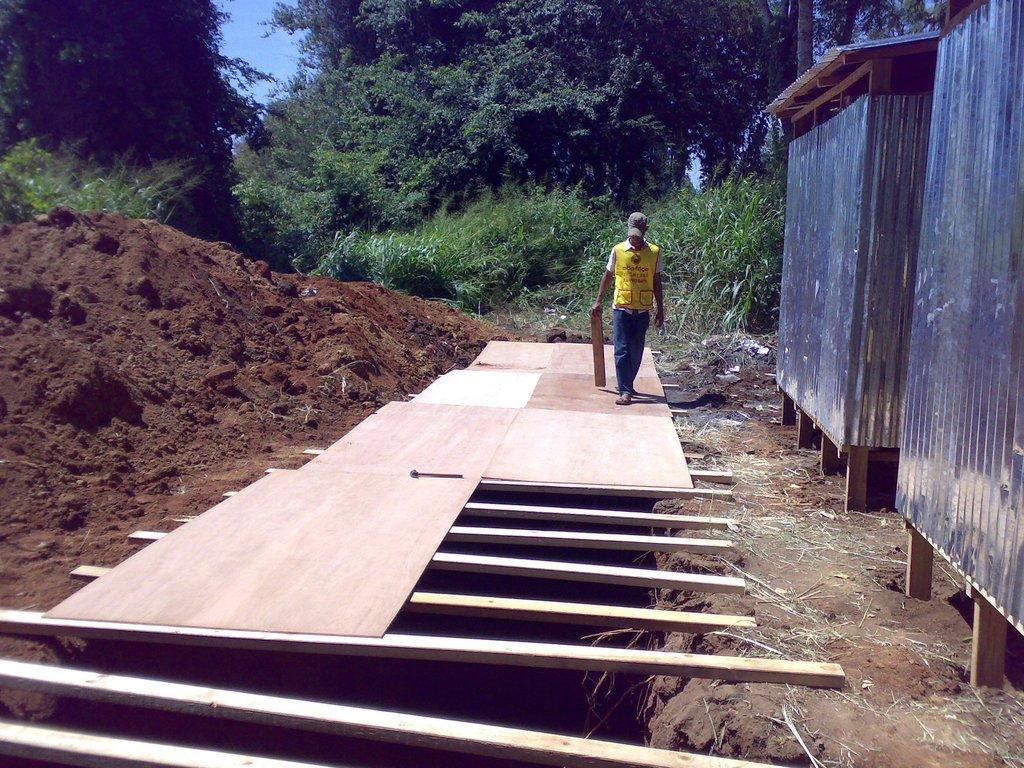In one or two sentences, can you explain what this image depicts? A person is on a wooden surface. This man is holding a wooden object. This is metal wall, soil and trees. Sky is in blue color. 